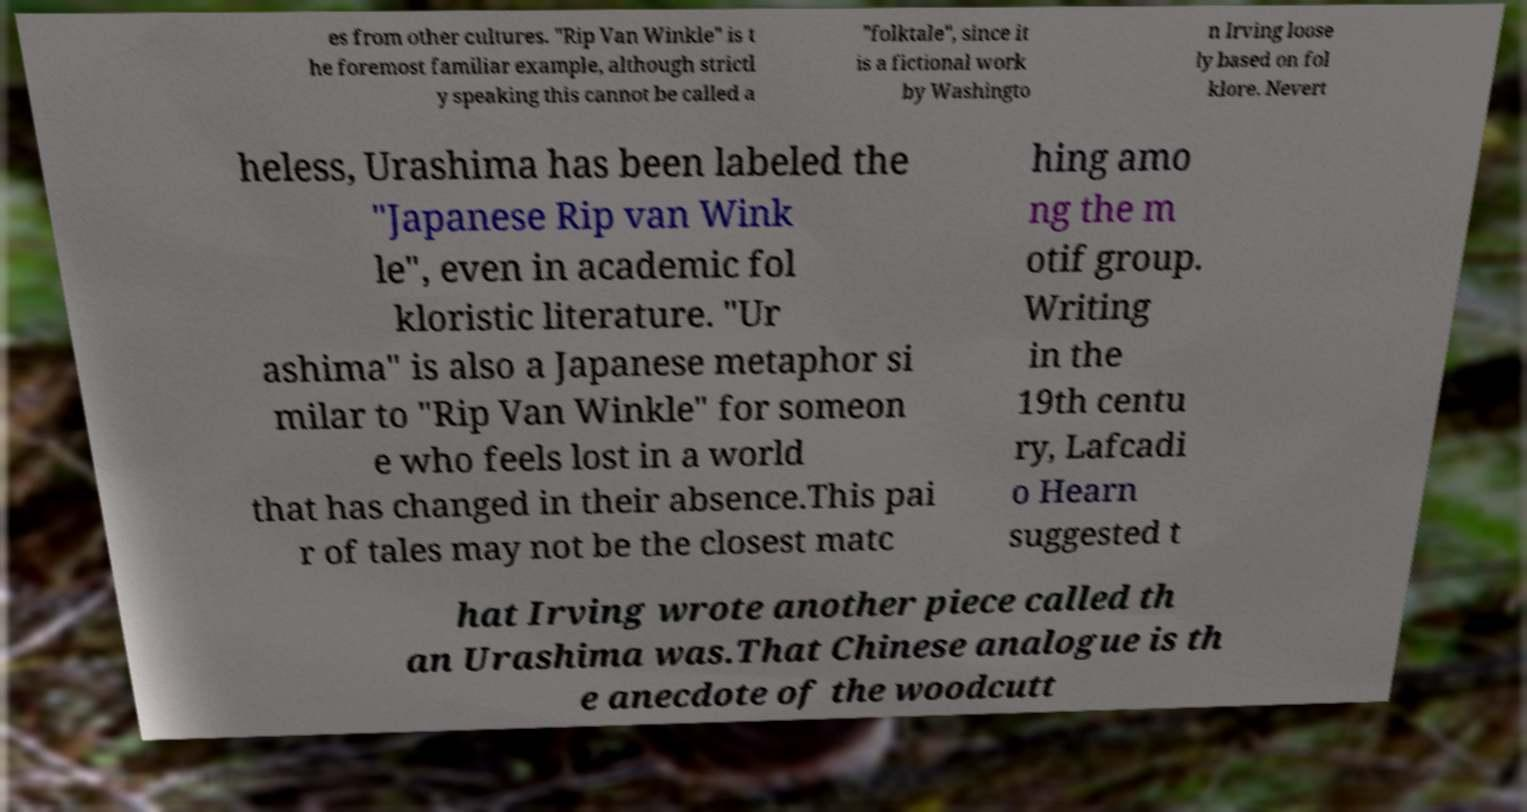Can you accurately transcribe the text from the provided image for me? es from other cultures. "Rip Van Winkle" is t he foremost familiar example, although strictl y speaking this cannot be called a "folktale", since it is a fictional work by Washingto n Irving loose ly based on fol klore. Nevert heless, Urashima has been labeled the "Japanese Rip van Wink le", even in academic fol kloristic literature. "Ur ashima" is also a Japanese metaphor si milar to "Rip Van Winkle" for someon e who feels lost in a world that has changed in their absence.This pai r of tales may not be the closest matc hing amo ng the m otif group. Writing in the 19th centu ry, Lafcadi o Hearn suggested t hat Irving wrote another piece called th an Urashima was.That Chinese analogue is th e anecdote of the woodcutt 